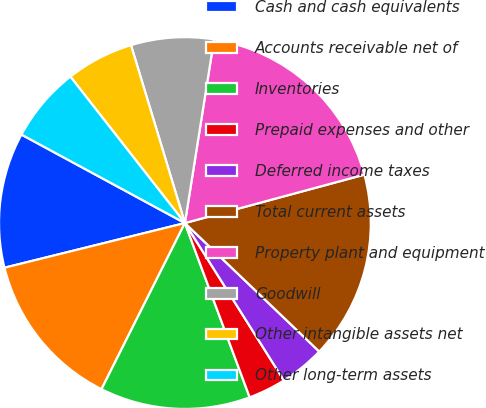<chart> <loc_0><loc_0><loc_500><loc_500><pie_chart><fcel>Cash and cash equivalents<fcel>Accounts receivable net of<fcel>Inventories<fcel>Prepaid expenses and other<fcel>Deferred income taxes<fcel>Total current assets<fcel>Property plant and equipment<fcel>Goodwill<fcel>Other intangible assets net<fcel>Other long-term assets<nl><fcel>11.76%<fcel>13.73%<fcel>13.07%<fcel>3.27%<fcel>3.92%<fcel>16.34%<fcel>18.3%<fcel>7.19%<fcel>5.88%<fcel>6.54%<nl></chart> 